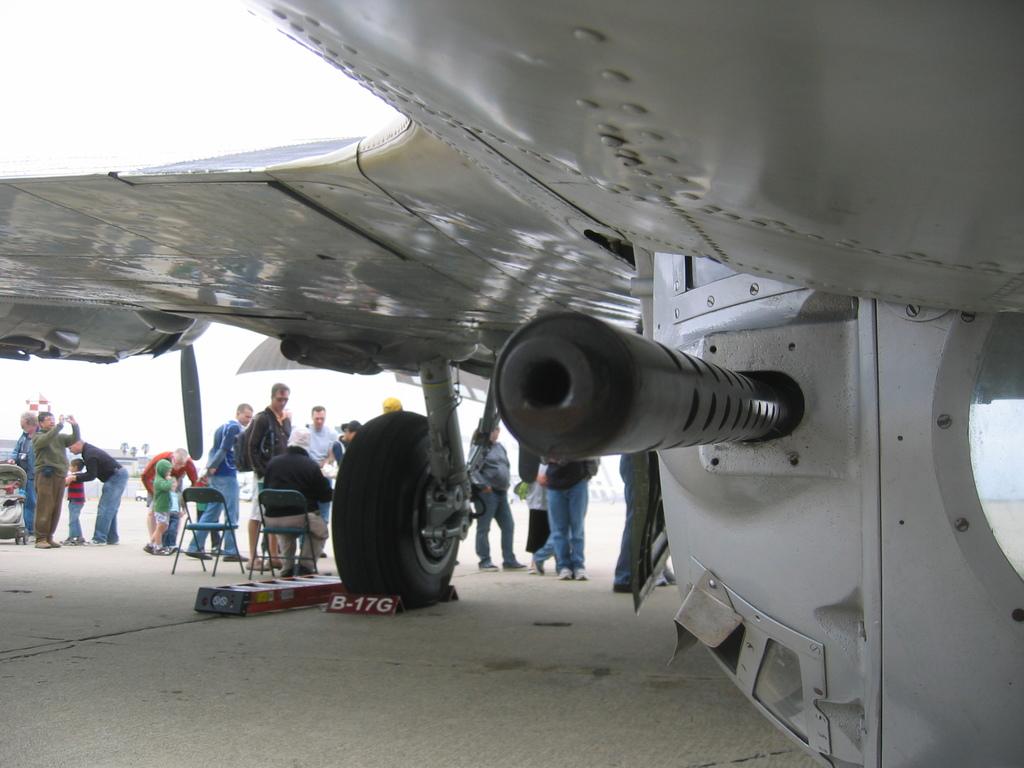What is the letter and number combo under the wheel?
Offer a terse response. B-17g. 